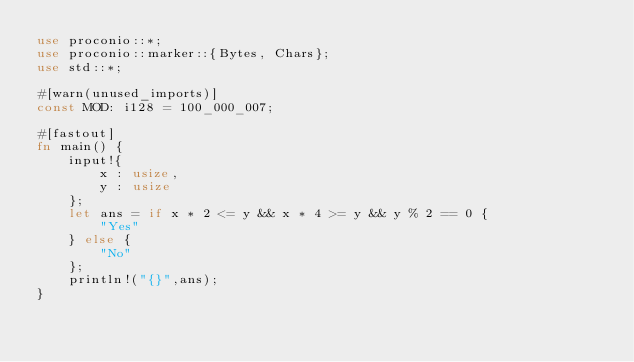<code> <loc_0><loc_0><loc_500><loc_500><_Rust_>use proconio::*;
use proconio::marker::{Bytes, Chars};
use std::*;

#[warn(unused_imports)]
const MOD: i128 = 100_000_007;

#[fastout]
fn main() {
    input!{
        x : usize,
        y : usize
    };
    let ans = if x * 2 <= y && x * 4 >= y && y % 2 == 0 {
        "Yes"
    } else {
        "No"
    };
    println!("{}",ans);
}
</code> 